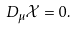<formula> <loc_0><loc_0><loc_500><loc_500>D _ { \mu } \mathcal { X } = 0 .</formula> 